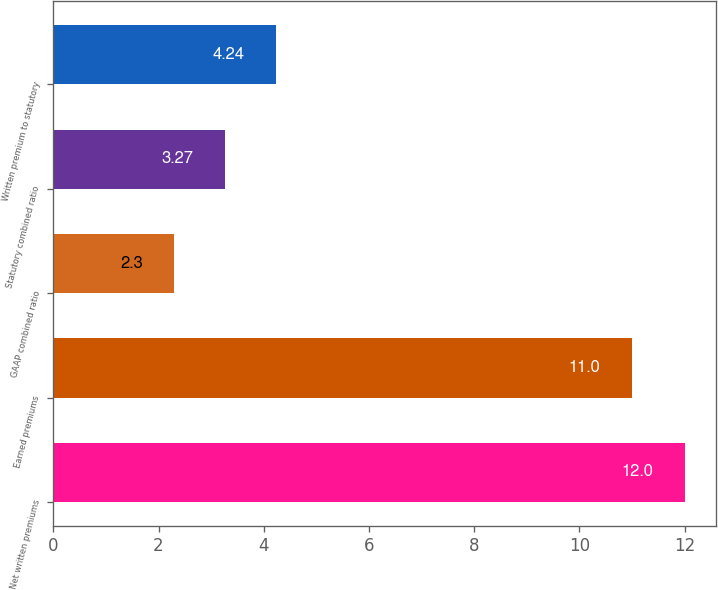Convert chart. <chart><loc_0><loc_0><loc_500><loc_500><bar_chart><fcel>Net written premiums<fcel>Earned premiums<fcel>GAAP combined ratio<fcel>Statutory combined ratio<fcel>Written premium to statutory<nl><fcel>12<fcel>11<fcel>2.3<fcel>3.27<fcel>4.24<nl></chart> 